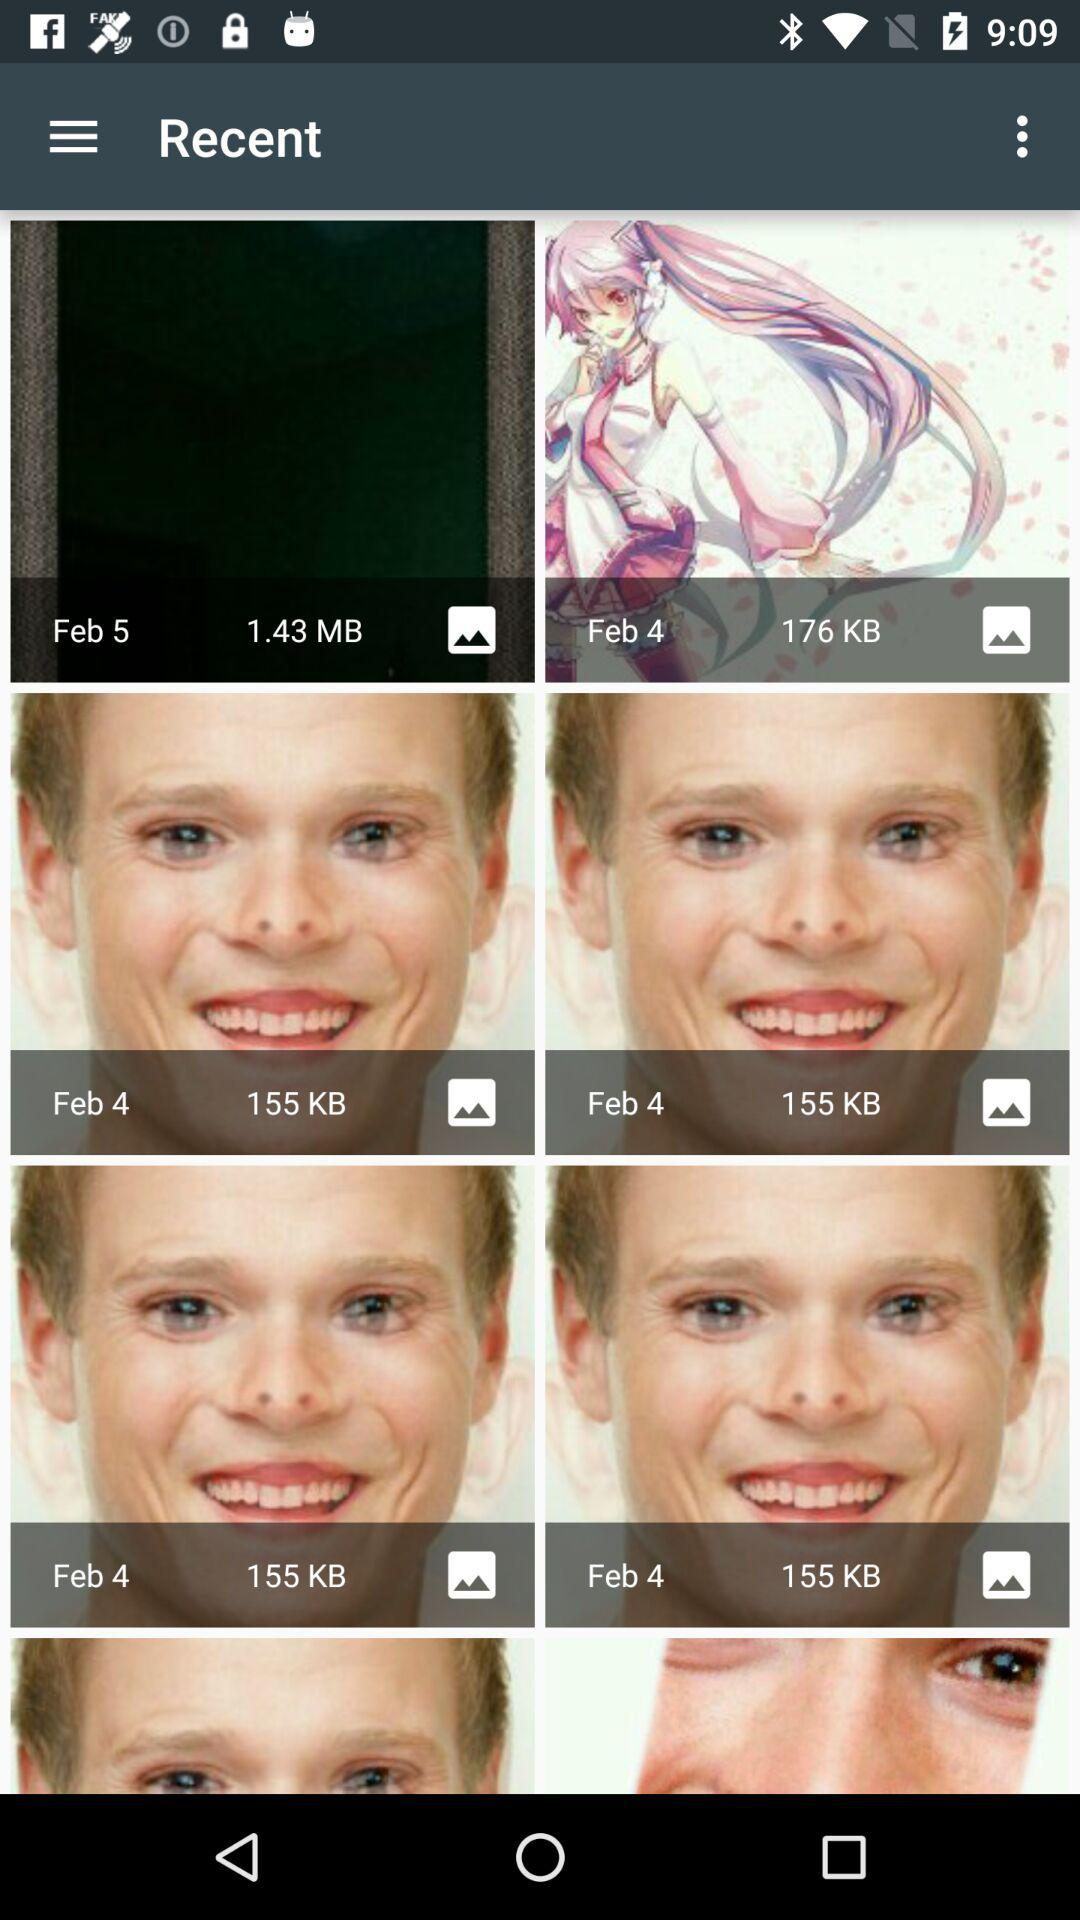On which date was the 176 KB image clicked? The 176 KB image was clicked on February 4. 